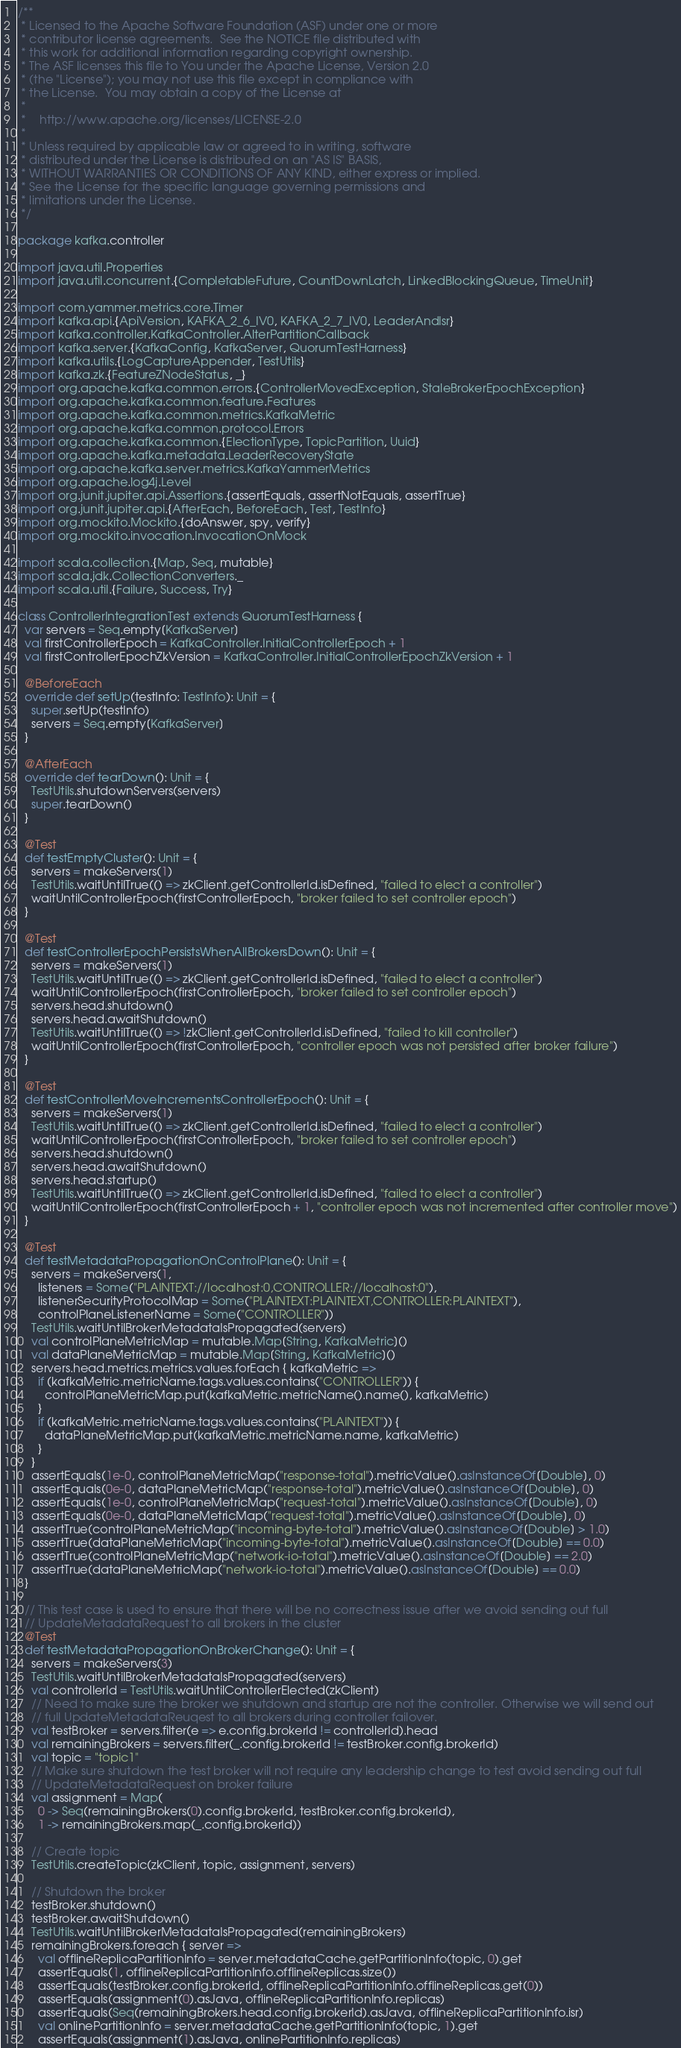<code> <loc_0><loc_0><loc_500><loc_500><_Scala_>/**
 * Licensed to the Apache Software Foundation (ASF) under one or more
 * contributor license agreements.  See the NOTICE file distributed with
 * this work for additional information regarding copyright ownership.
 * The ASF licenses this file to You under the Apache License, Version 2.0
 * (the "License"); you may not use this file except in compliance with
 * the License.  You may obtain a copy of the License at
 *
 *    http://www.apache.org/licenses/LICENSE-2.0
 *
 * Unless required by applicable law or agreed to in writing, software
 * distributed under the License is distributed on an "AS IS" BASIS,
 * WITHOUT WARRANTIES OR CONDITIONS OF ANY KIND, either express or implied.
 * See the License for the specific language governing permissions and
 * limitations under the License.
 */

package kafka.controller

import java.util.Properties
import java.util.concurrent.{CompletableFuture, CountDownLatch, LinkedBlockingQueue, TimeUnit}

import com.yammer.metrics.core.Timer
import kafka.api.{ApiVersion, KAFKA_2_6_IV0, KAFKA_2_7_IV0, LeaderAndIsr}
import kafka.controller.KafkaController.AlterPartitionCallback
import kafka.server.{KafkaConfig, KafkaServer, QuorumTestHarness}
import kafka.utils.{LogCaptureAppender, TestUtils}
import kafka.zk.{FeatureZNodeStatus, _}
import org.apache.kafka.common.errors.{ControllerMovedException, StaleBrokerEpochException}
import org.apache.kafka.common.feature.Features
import org.apache.kafka.common.metrics.KafkaMetric
import org.apache.kafka.common.protocol.Errors
import org.apache.kafka.common.{ElectionType, TopicPartition, Uuid}
import org.apache.kafka.metadata.LeaderRecoveryState
import org.apache.kafka.server.metrics.KafkaYammerMetrics
import org.apache.log4j.Level
import org.junit.jupiter.api.Assertions.{assertEquals, assertNotEquals, assertTrue}
import org.junit.jupiter.api.{AfterEach, BeforeEach, Test, TestInfo}
import org.mockito.Mockito.{doAnswer, spy, verify}
import org.mockito.invocation.InvocationOnMock

import scala.collection.{Map, Seq, mutable}
import scala.jdk.CollectionConverters._
import scala.util.{Failure, Success, Try}

class ControllerIntegrationTest extends QuorumTestHarness {
  var servers = Seq.empty[KafkaServer]
  val firstControllerEpoch = KafkaController.InitialControllerEpoch + 1
  val firstControllerEpochZkVersion = KafkaController.InitialControllerEpochZkVersion + 1

  @BeforeEach
  override def setUp(testInfo: TestInfo): Unit = {
    super.setUp(testInfo)
    servers = Seq.empty[KafkaServer]
  }

  @AfterEach
  override def tearDown(): Unit = {
    TestUtils.shutdownServers(servers)
    super.tearDown()
  }

  @Test
  def testEmptyCluster(): Unit = {
    servers = makeServers(1)
    TestUtils.waitUntilTrue(() => zkClient.getControllerId.isDefined, "failed to elect a controller")
    waitUntilControllerEpoch(firstControllerEpoch, "broker failed to set controller epoch")
  }

  @Test
  def testControllerEpochPersistsWhenAllBrokersDown(): Unit = {
    servers = makeServers(1)
    TestUtils.waitUntilTrue(() => zkClient.getControllerId.isDefined, "failed to elect a controller")
    waitUntilControllerEpoch(firstControllerEpoch, "broker failed to set controller epoch")
    servers.head.shutdown()
    servers.head.awaitShutdown()
    TestUtils.waitUntilTrue(() => !zkClient.getControllerId.isDefined, "failed to kill controller")
    waitUntilControllerEpoch(firstControllerEpoch, "controller epoch was not persisted after broker failure")
  }

  @Test
  def testControllerMoveIncrementsControllerEpoch(): Unit = {
    servers = makeServers(1)
    TestUtils.waitUntilTrue(() => zkClient.getControllerId.isDefined, "failed to elect a controller")
    waitUntilControllerEpoch(firstControllerEpoch, "broker failed to set controller epoch")
    servers.head.shutdown()
    servers.head.awaitShutdown()
    servers.head.startup()
    TestUtils.waitUntilTrue(() => zkClient.getControllerId.isDefined, "failed to elect a controller")
    waitUntilControllerEpoch(firstControllerEpoch + 1, "controller epoch was not incremented after controller move")
  }

  @Test
  def testMetadataPropagationOnControlPlane(): Unit = {
    servers = makeServers(1,
      listeners = Some("PLAINTEXT://localhost:0,CONTROLLER://localhost:0"),
      listenerSecurityProtocolMap = Some("PLAINTEXT:PLAINTEXT,CONTROLLER:PLAINTEXT"),
      controlPlaneListenerName = Some("CONTROLLER"))
    TestUtils.waitUntilBrokerMetadataIsPropagated(servers)
    val controlPlaneMetricMap = mutable.Map[String, KafkaMetric]()
    val dataPlaneMetricMap = mutable.Map[String, KafkaMetric]()
    servers.head.metrics.metrics.values.forEach { kafkaMetric =>
      if (kafkaMetric.metricName.tags.values.contains("CONTROLLER")) {
        controlPlaneMetricMap.put(kafkaMetric.metricName().name(), kafkaMetric)
      }
      if (kafkaMetric.metricName.tags.values.contains("PLAINTEXT")) {
        dataPlaneMetricMap.put(kafkaMetric.metricName.name, kafkaMetric)
      }
    }
    assertEquals(1e-0, controlPlaneMetricMap("response-total").metricValue().asInstanceOf[Double], 0)
    assertEquals(0e-0, dataPlaneMetricMap("response-total").metricValue().asInstanceOf[Double], 0)
    assertEquals(1e-0, controlPlaneMetricMap("request-total").metricValue().asInstanceOf[Double], 0)
    assertEquals(0e-0, dataPlaneMetricMap("request-total").metricValue().asInstanceOf[Double], 0)
    assertTrue(controlPlaneMetricMap("incoming-byte-total").metricValue().asInstanceOf[Double] > 1.0)
    assertTrue(dataPlaneMetricMap("incoming-byte-total").metricValue().asInstanceOf[Double] == 0.0)
    assertTrue(controlPlaneMetricMap("network-io-total").metricValue().asInstanceOf[Double] == 2.0)
    assertTrue(dataPlaneMetricMap("network-io-total").metricValue().asInstanceOf[Double] == 0.0)
  }

  // This test case is used to ensure that there will be no correctness issue after we avoid sending out full
  // UpdateMetadataRequest to all brokers in the cluster
  @Test
  def testMetadataPropagationOnBrokerChange(): Unit = {
    servers = makeServers(3)
    TestUtils.waitUntilBrokerMetadataIsPropagated(servers)
    val controllerId = TestUtils.waitUntilControllerElected(zkClient)
    // Need to make sure the broker we shutdown and startup are not the controller. Otherwise we will send out
    // full UpdateMetadataReuqest to all brokers during controller failover.
    val testBroker = servers.filter(e => e.config.brokerId != controllerId).head
    val remainingBrokers = servers.filter(_.config.brokerId != testBroker.config.brokerId)
    val topic = "topic1"
    // Make sure shutdown the test broker will not require any leadership change to test avoid sending out full
    // UpdateMetadataRequest on broker failure
    val assignment = Map(
      0 -> Seq(remainingBrokers(0).config.brokerId, testBroker.config.brokerId),
      1 -> remainingBrokers.map(_.config.brokerId))

    // Create topic
    TestUtils.createTopic(zkClient, topic, assignment, servers)

    // Shutdown the broker
    testBroker.shutdown()
    testBroker.awaitShutdown()
    TestUtils.waitUntilBrokerMetadataIsPropagated(remainingBrokers)
    remainingBrokers.foreach { server =>
      val offlineReplicaPartitionInfo = server.metadataCache.getPartitionInfo(topic, 0).get
      assertEquals(1, offlineReplicaPartitionInfo.offlineReplicas.size())
      assertEquals(testBroker.config.brokerId, offlineReplicaPartitionInfo.offlineReplicas.get(0))
      assertEquals(assignment(0).asJava, offlineReplicaPartitionInfo.replicas)
      assertEquals(Seq(remainingBrokers.head.config.brokerId).asJava, offlineReplicaPartitionInfo.isr)
      val onlinePartitionInfo = server.metadataCache.getPartitionInfo(topic, 1).get
      assertEquals(assignment(1).asJava, onlinePartitionInfo.replicas)</code> 